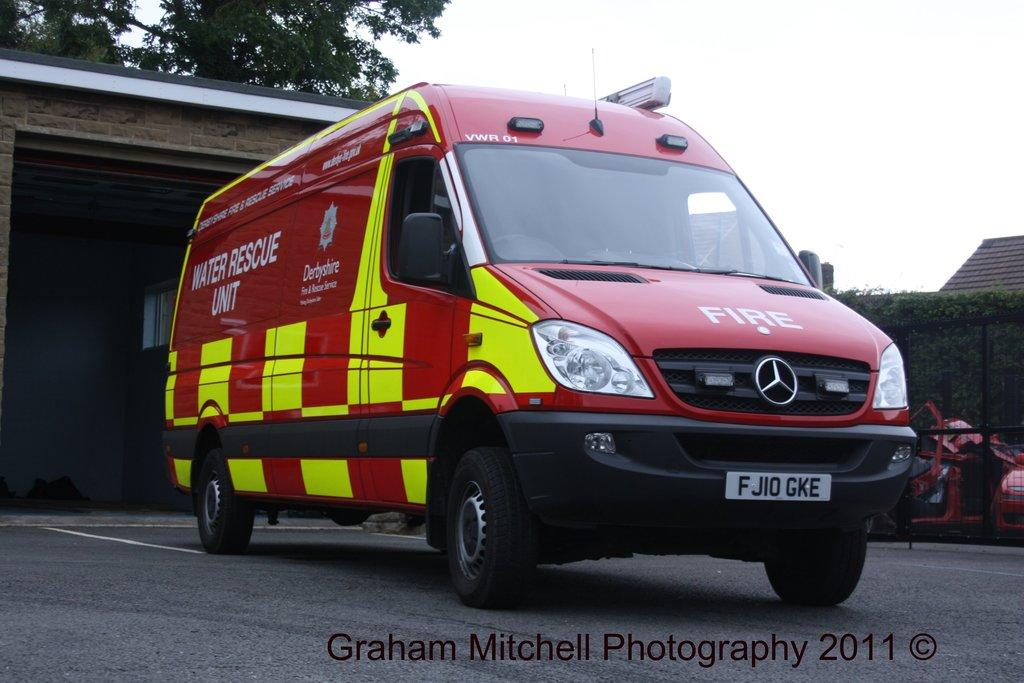Provide a one-sentence caption for the provided image. A large, red emergency vehicle with "fire" on the front and "water rescue unit" on the side. 